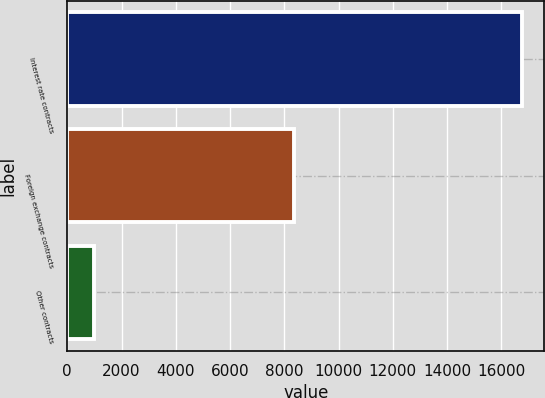Convert chart to OTSL. <chart><loc_0><loc_0><loc_500><loc_500><bar_chart><fcel>Interest rate contracts<fcel>Foreign exchange contracts<fcel>Other contracts<nl><fcel>16750<fcel>8366<fcel>981<nl></chart> 